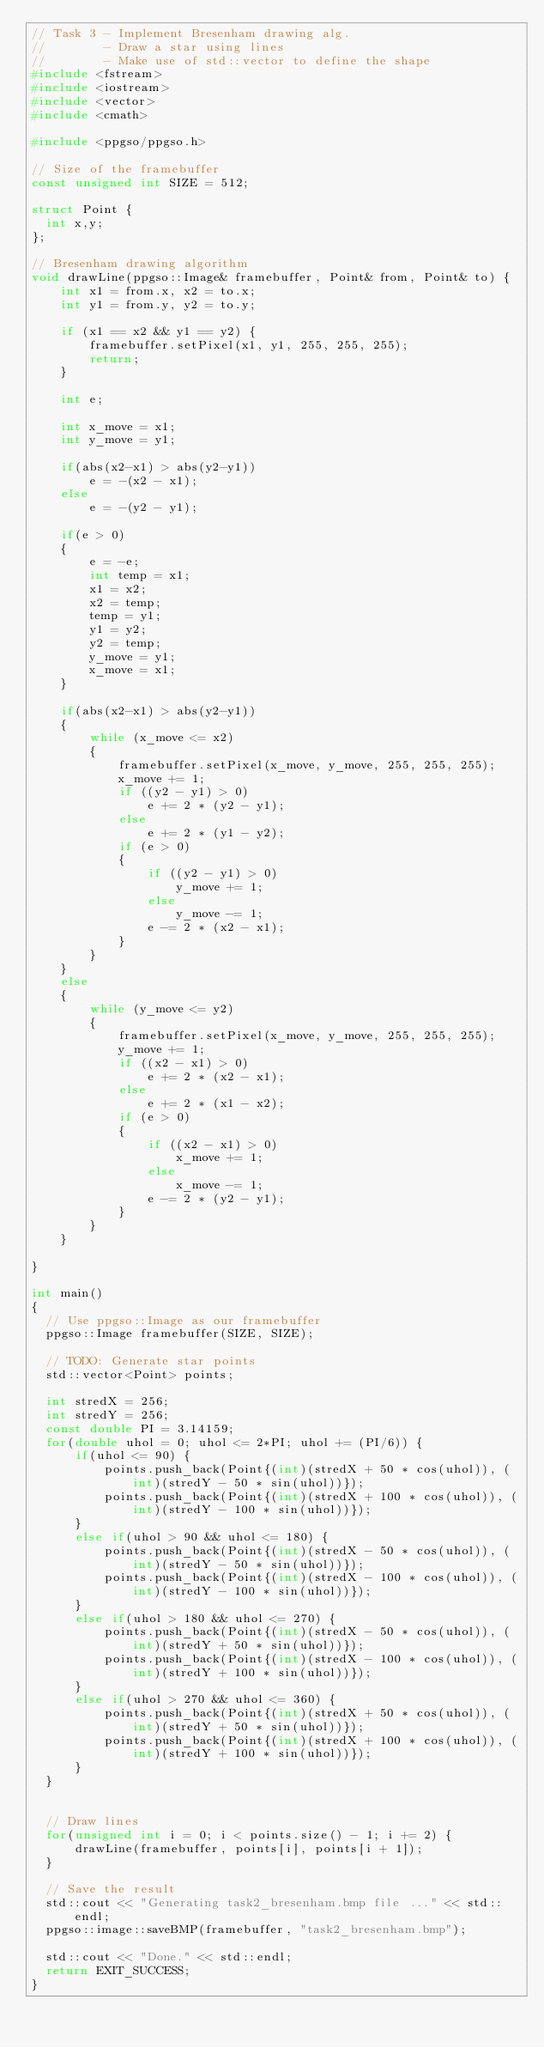<code> <loc_0><loc_0><loc_500><loc_500><_C++_>// Task 3 - Implement Bresenham drawing alg.
//        - Draw a star using lines
//        - Make use of std::vector to define the shape
#include <fstream>
#include <iostream>
#include <vector>
#include <cmath>

#include <ppgso/ppgso.h>

// Size of the framebuffer
const unsigned int SIZE = 512;

struct Point {
  int x,y;
};

// Bresenham drawing algorithm
void drawLine(ppgso::Image& framebuffer, Point& from, Point& to) {
    int x1 = from.x, x2 = to.x;
    int y1 = from.y, y2 = to.y;

    if (x1 == x2 && y1 == y2) {
        framebuffer.setPixel(x1, y1, 255, 255, 255);
        return;
    }

    int e;

    int x_move = x1;
    int y_move = y1;

    if(abs(x2-x1) > abs(y2-y1))
        e = -(x2 - x1);
    else
        e = -(y2 - y1);

    if(e > 0)
    {
        e = -e;
        int temp = x1;
        x1 = x2;
        x2 = temp;
        temp = y1;
        y1 = y2;
        y2 = temp;
        y_move = y1;
        x_move = x1;
    }

    if(abs(x2-x1) > abs(y2-y1))
    {
        while (x_move <= x2)
        {
            framebuffer.setPixel(x_move, y_move, 255, 255, 255);
            x_move += 1;
            if ((y2 - y1) > 0)
                e += 2 * (y2 - y1);
            else
                e += 2 * (y1 - y2);
            if (e > 0)
            {
                if ((y2 - y1) > 0)
                    y_move += 1;
                else
                    y_move -= 1;
                e -= 2 * (x2 - x1);
            }
        }
    }
    else
    {
        while (y_move <= y2)
        {
            framebuffer.setPixel(x_move, y_move, 255, 255, 255);
            y_move += 1;
            if ((x2 - x1) > 0)
                e += 2 * (x2 - x1);
            else
                e += 2 * (x1 - x2);
            if (e > 0)
            {
                if ((x2 - x1) > 0)
                    x_move += 1;
                else
                    x_move -= 1;
                e -= 2 * (y2 - y1);
            }
        }
    }

}

int main()
{
  // Use ppgso::Image as our framebuffer
  ppgso::Image framebuffer(SIZE, SIZE);

  // TODO: Generate star points
  std::vector<Point> points;

  int stredX = 256;
  int stredY = 256;
  const double PI = 3.14159;
  for(double uhol = 0; uhol <= 2*PI; uhol += (PI/6)) {
      if(uhol <= 90) {
          points.push_back(Point{(int)(stredX + 50 * cos(uhol)), (int)(stredY - 50 * sin(uhol))});
          points.push_back(Point{(int)(stredX + 100 * cos(uhol)), (int)(stredY - 100 * sin(uhol))});
      }
      else if(uhol > 90 && uhol <= 180) {
          points.push_back(Point{(int)(stredX - 50 * cos(uhol)), (int)(stredY - 50 * sin(uhol))});
          points.push_back(Point{(int)(stredX - 100 * cos(uhol)), (int)(stredY - 100 * sin(uhol))});
      }
      else if(uhol > 180 && uhol <= 270) {
          points.push_back(Point{(int)(stredX - 50 * cos(uhol)), (int)(stredY + 50 * sin(uhol))});
          points.push_back(Point{(int)(stredX - 100 * cos(uhol)), (int)(stredY + 100 * sin(uhol))});
      }
      else if(uhol > 270 && uhol <= 360) {
          points.push_back(Point{(int)(stredX + 50 * cos(uhol)), (int)(stredY + 50 * sin(uhol))});
          points.push_back(Point{(int)(stredX + 100 * cos(uhol)), (int)(stredY + 100 * sin(uhol))});
      }
  }


  // Draw lines
  for(unsigned int i = 0; i < points.size() - 1; i += 2) {
      drawLine(framebuffer, points[i], points[i + 1]);
  }

  // Save the result
  std::cout << "Generating task2_bresenham.bmp file ..." << std::endl;
  ppgso::image::saveBMP(framebuffer, "task2_bresenham.bmp");

  std::cout << "Done." << std::endl;
  return EXIT_SUCCESS;
}

</code> 